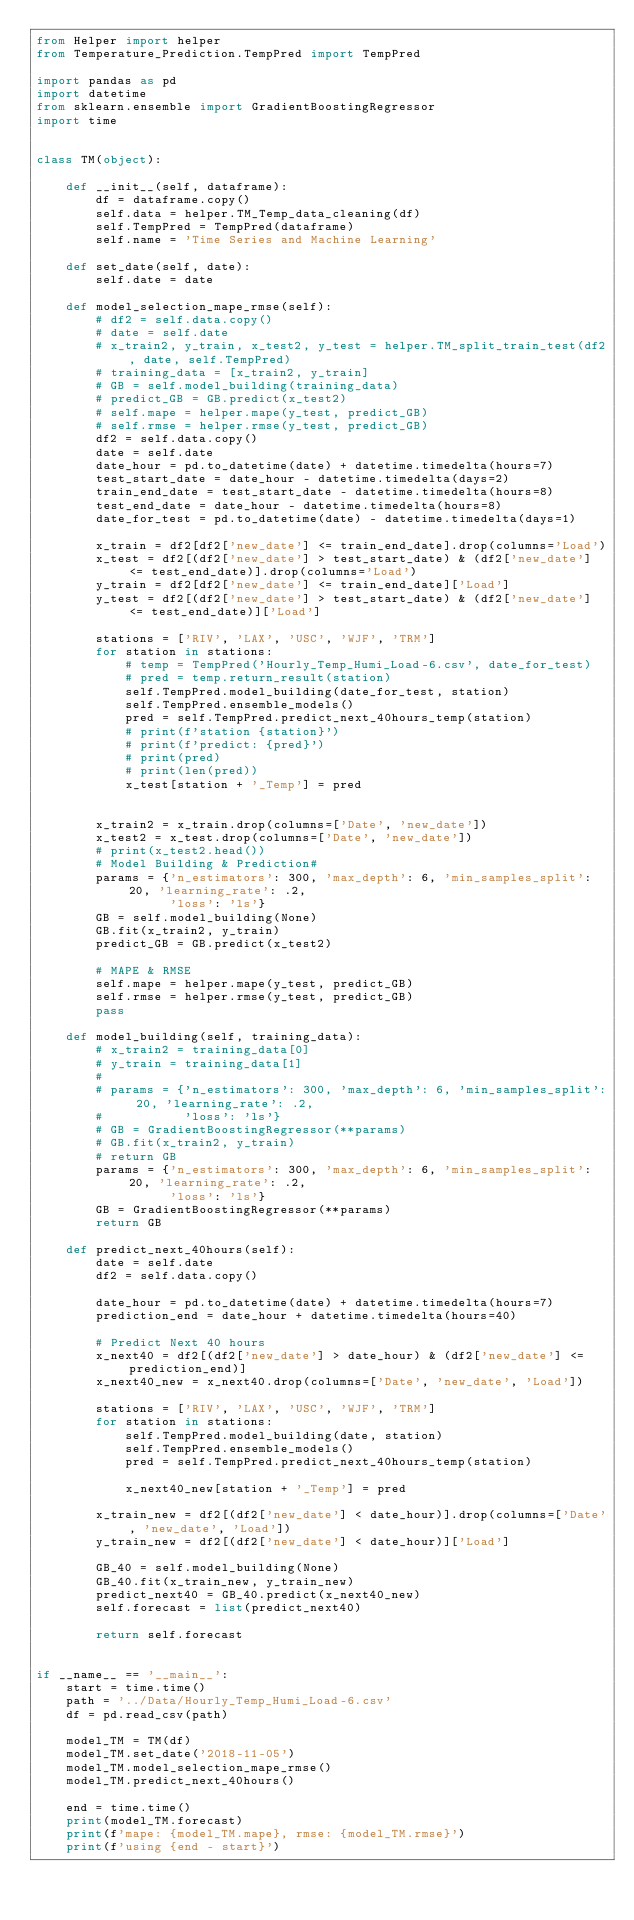Convert code to text. <code><loc_0><loc_0><loc_500><loc_500><_Python_>from Helper import helper
from Temperature_Prediction.TempPred import TempPred

import pandas as pd
import datetime
from sklearn.ensemble import GradientBoostingRegressor
import time


class TM(object):

    def __init__(self, dataframe):
        df = dataframe.copy()
        self.data = helper.TM_Temp_data_cleaning(df)
        self.TempPred = TempPred(dataframe)
        self.name = 'Time Series and Machine Learning'

    def set_date(self, date):
        self.date = date

    def model_selection_mape_rmse(self):
        # df2 = self.data.copy()
        # date = self.date
        # x_train2, y_train, x_test2, y_test = helper.TM_split_train_test(df2, date, self.TempPred)
        # training_data = [x_train2, y_train]
        # GB = self.model_building(training_data)
        # predict_GB = GB.predict(x_test2)
        # self.mape = helper.mape(y_test, predict_GB)
        # self.rmse = helper.rmse(y_test, predict_GB)
        df2 = self.data.copy()
        date = self.date
        date_hour = pd.to_datetime(date) + datetime.timedelta(hours=7)
        test_start_date = date_hour - datetime.timedelta(days=2)
        train_end_date = test_start_date - datetime.timedelta(hours=8)
        test_end_date = date_hour - datetime.timedelta(hours=8)
        date_for_test = pd.to_datetime(date) - datetime.timedelta(days=1)

        x_train = df2[df2['new_date'] <= train_end_date].drop(columns='Load')
        x_test = df2[(df2['new_date'] > test_start_date) & (df2['new_date'] <= test_end_date)].drop(columns='Load')
        y_train = df2[df2['new_date'] <= train_end_date]['Load']
        y_test = df2[(df2['new_date'] > test_start_date) & (df2['new_date'] <= test_end_date)]['Load']

        stations = ['RIV', 'LAX', 'USC', 'WJF', 'TRM']
        for station in stations:
            # temp = TempPred('Hourly_Temp_Humi_Load-6.csv', date_for_test)
            # pred = temp.return_result(station)
            self.TempPred.model_building(date_for_test, station)
            self.TempPred.ensemble_models()
            pred = self.TempPred.predict_next_40hours_temp(station)
            # print(f'station {station}')
            # print(f'predict: {pred}')
            # print(pred)
            # print(len(pred))
            x_test[station + '_Temp'] = pred


        x_train2 = x_train.drop(columns=['Date', 'new_date'])
        x_test2 = x_test.drop(columns=['Date', 'new_date'])
        # print(x_test2.head())
        # Model Building & Prediction#
        params = {'n_estimators': 300, 'max_depth': 6, 'min_samples_split': 20, 'learning_rate': .2,
                  'loss': 'ls'}
        GB = self.model_building(None)
        GB.fit(x_train2, y_train)
        predict_GB = GB.predict(x_test2)

        # MAPE & RMSE
        self.mape = helper.mape(y_test, predict_GB)
        self.rmse = helper.rmse(y_test, predict_GB)
        pass

    def model_building(self, training_data):
        # x_train2 = training_data[0]
        # y_train = training_data[1]
        #
        # params = {'n_estimators': 300, 'max_depth': 6, 'min_samples_split': 20, 'learning_rate': .2,
        #           'loss': 'ls'}
        # GB = GradientBoostingRegressor(**params)
        # GB.fit(x_train2, y_train)
        # return GB
        params = {'n_estimators': 300, 'max_depth': 6, 'min_samples_split': 20, 'learning_rate': .2,
                  'loss': 'ls'}
        GB = GradientBoostingRegressor(**params)
        return GB

    def predict_next_40hours(self):
        date = self.date
        df2 = self.data.copy()

        date_hour = pd.to_datetime(date) + datetime.timedelta(hours=7)
        prediction_end = date_hour + datetime.timedelta(hours=40)

        # Predict Next 40 hours
        x_next40 = df2[(df2['new_date'] > date_hour) & (df2['new_date'] <= prediction_end)]
        x_next40_new = x_next40.drop(columns=['Date', 'new_date', 'Load'])

        stations = ['RIV', 'LAX', 'USC', 'WJF', 'TRM']
        for station in stations:
            self.TempPred.model_building(date, station)
            self.TempPred.ensemble_models()
            pred = self.TempPred.predict_next_40hours_temp(station)

            x_next40_new[station + '_Temp'] = pred

        x_train_new = df2[(df2['new_date'] < date_hour)].drop(columns=['Date', 'new_date', 'Load'])
        y_train_new = df2[(df2['new_date'] < date_hour)]['Load']

        GB_40 = self.model_building(None)
        GB_40.fit(x_train_new, y_train_new)
        predict_next40 = GB_40.predict(x_next40_new)
        self.forecast = list(predict_next40)

        return self.forecast


if __name__ == '__main__':
    start = time.time()
    path = '../Data/Hourly_Temp_Humi_Load-6.csv'
    df = pd.read_csv(path)

    model_TM = TM(df)
    model_TM.set_date('2018-11-05')
    model_TM.model_selection_mape_rmse()
    model_TM.predict_next_40hours()

    end = time.time()
    print(model_TM.forecast)
    print(f'mape: {model_TM.mape}, rmse: {model_TM.rmse}')
    print(f'using {end - start}')
</code> 